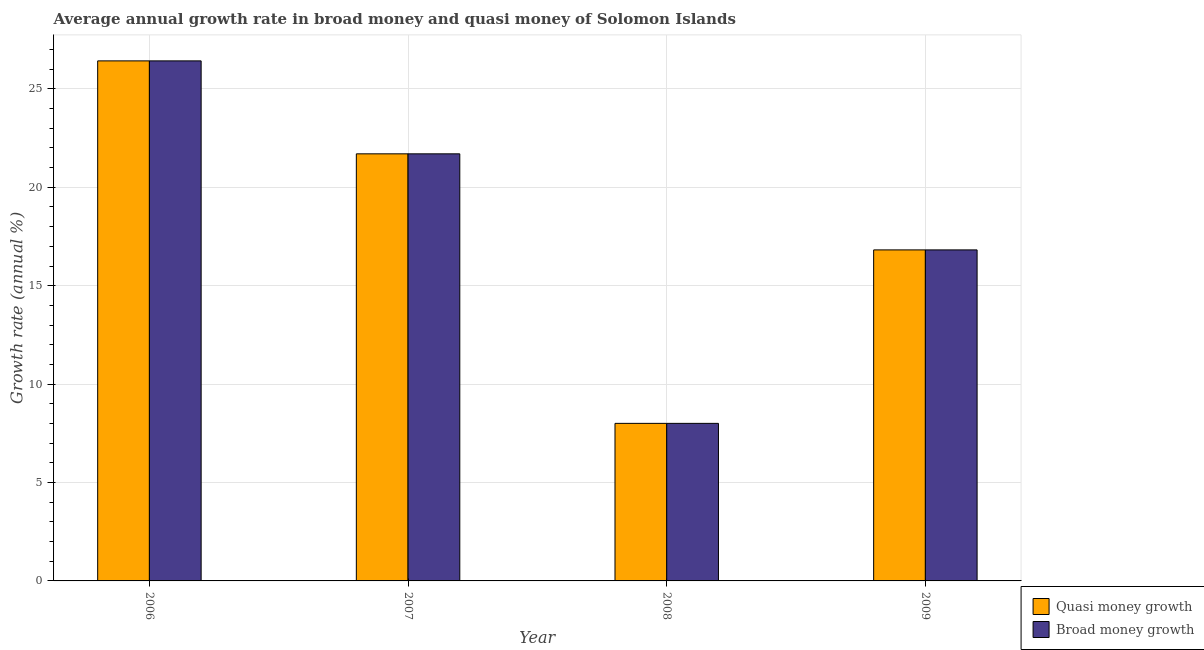How many groups of bars are there?
Your answer should be compact. 4. How many bars are there on the 2nd tick from the right?
Keep it short and to the point. 2. What is the label of the 1st group of bars from the left?
Your answer should be compact. 2006. In how many cases, is the number of bars for a given year not equal to the number of legend labels?
Provide a short and direct response. 0. What is the annual growth rate in broad money in 2008?
Keep it short and to the point. 8.01. Across all years, what is the maximum annual growth rate in broad money?
Provide a short and direct response. 26.42. Across all years, what is the minimum annual growth rate in broad money?
Your answer should be compact. 8.01. In which year was the annual growth rate in quasi money maximum?
Keep it short and to the point. 2006. In which year was the annual growth rate in broad money minimum?
Provide a succinct answer. 2008. What is the total annual growth rate in quasi money in the graph?
Provide a short and direct response. 72.95. What is the difference between the annual growth rate in quasi money in 2006 and that in 2008?
Your answer should be compact. 18.42. What is the difference between the annual growth rate in quasi money in 2006 and the annual growth rate in broad money in 2007?
Make the answer very short. 4.72. What is the average annual growth rate in quasi money per year?
Keep it short and to the point. 18.24. In the year 2006, what is the difference between the annual growth rate in broad money and annual growth rate in quasi money?
Provide a short and direct response. 0. What is the ratio of the annual growth rate in quasi money in 2007 to that in 2009?
Make the answer very short. 1.29. What is the difference between the highest and the second highest annual growth rate in broad money?
Keep it short and to the point. 4.72. What is the difference between the highest and the lowest annual growth rate in quasi money?
Provide a short and direct response. 18.42. Is the sum of the annual growth rate in quasi money in 2007 and 2008 greater than the maximum annual growth rate in broad money across all years?
Ensure brevity in your answer.  Yes. What does the 1st bar from the left in 2009 represents?
Keep it short and to the point. Quasi money growth. What does the 2nd bar from the right in 2009 represents?
Provide a short and direct response. Quasi money growth. How many bars are there?
Ensure brevity in your answer.  8. Are all the bars in the graph horizontal?
Offer a very short reply. No. What is the difference between two consecutive major ticks on the Y-axis?
Offer a very short reply. 5. Does the graph contain any zero values?
Your response must be concise. No. Does the graph contain grids?
Give a very brief answer. Yes. How many legend labels are there?
Ensure brevity in your answer.  2. What is the title of the graph?
Make the answer very short. Average annual growth rate in broad money and quasi money of Solomon Islands. Does "Register a business" appear as one of the legend labels in the graph?
Provide a short and direct response. No. What is the label or title of the Y-axis?
Ensure brevity in your answer.  Growth rate (annual %). What is the Growth rate (annual %) in Quasi money growth in 2006?
Keep it short and to the point. 26.42. What is the Growth rate (annual %) in Broad money growth in 2006?
Offer a terse response. 26.42. What is the Growth rate (annual %) in Quasi money growth in 2007?
Offer a terse response. 21.7. What is the Growth rate (annual %) of Broad money growth in 2007?
Ensure brevity in your answer.  21.7. What is the Growth rate (annual %) in Quasi money growth in 2008?
Offer a very short reply. 8.01. What is the Growth rate (annual %) of Broad money growth in 2008?
Ensure brevity in your answer.  8.01. What is the Growth rate (annual %) in Quasi money growth in 2009?
Give a very brief answer. 16.82. What is the Growth rate (annual %) in Broad money growth in 2009?
Your response must be concise. 16.82. Across all years, what is the maximum Growth rate (annual %) of Quasi money growth?
Your answer should be compact. 26.42. Across all years, what is the maximum Growth rate (annual %) of Broad money growth?
Offer a terse response. 26.42. Across all years, what is the minimum Growth rate (annual %) of Quasi money growth?
Offer a very short reply. 8.01. Across all years, what is the minimum Growth rate (annual %) in Broad money growth?
Offer a very short reply. 8.01. What is the total Growth rate (annual %) of Quasi money growth in the graph?
Provide a short and direct response. 72.95. What is the total Growth rate (annual %) in Broad money growth in the graph?
Your answer should be very brief. 72.95. What is the difference between the Growth rate (annual %) in Quasi money growth in 2006 and that in 2007?
Provide a succinct answer. 4.72. What is the difference between the Growth rate (annual %) of Broad money growth in 2006 and that in 2007?
Ensure brevity in your answer.  4.72. What is the difference between the Growth rate (annual %) of Quasi money growth in 2006 and that in 2008?
Your response must be concise. 18.42. What is the difference between the Growth rate (annual %) of Broad money growth in 2006 and that in 2008?
Keep it short and to the point. 18.42. What is the difference between the Growth rate (annual %) of Quasi money growth in 2006 and that in 2009?
Your response must be concise. 9.6. What is the difference between the Growth rate (annual %) of Broad money growth in 2006 and that in 2009?
Give a very brief answer. 9.6. What is the difference between the Growth rate (annual %) of Quasi money growth in 2007 and that in 2008?
Your answer should be very brief. 13.7. What is the difference between the Growth rate (annual %) of Broad money growth in 2007 and that in 2008?
Offer a very short reply. 13.7. What is the difference between the Growth rate (annual %) of Quasi money growth in 2007 and that in 2009?
Provide a succinct answer. 4.88. What is the difference between the Growth rate (annual %) of Broad money growth in 2007 and that in 2009?
Your answer should be compact. 4.88. What is the difference between the Growth rate (annual %) in Quasi money growth in 2008 and that in 2009?
Your answer should be compact. -8.81. What is the difference between the Growth rate (annual %) in Broad money growth in 2008 and that in 2009?
Offer a terse response. -8.81. What is the difference between the Growth rate (annual %) in Quasi money growth in 2006 and the Growth rate (annual %) in Broad money growth in 2007?
Provide a succinct answer. 4.72. What is the difference between the Growth rate (annual %) in Quasi money growth in 2006 and the Growth rate (annual %) in Broad money growth in 2008?
Your answer should be compact. 18.42. What is the difference between the Growth rate (annual %) in Quasi money growth in 2006 and the Growth rate (annual %) in Broad money growth in 2009?
Your answer should be compact. 9.6. What is the difference between the Growth rate (annual %) in Quasi money growth in 2007 and the Growth rate (annual %) in Broad money growth in 2008?
Provide a succinct answer. 13.7. What is the difference between the Growth rate (annual %) of Quasi money growth in 2007 and the Growth rate (annual %) of Broad money growth in 2009?
Give a very brief answer. 4.88. What is the difference between the Growth rate (annual %) in Quasi money growth in 2008 and the Growth rate (annual %) in Broad money growth in 2009?
Provide a short and direct response. -8.81. What is the average Growth rate (annual %) of Quasi money growth per year?
Offer a terse response. 18.24. What is the average Growth rate (annual %) in Broad money growth per year?
Offer a terse response. 18.24. In the year 2006, what is the difference between the Growth rate (annual %) of Quasi money growth and Growth rate (annual %) of Broad money growth?
Your answer should be very brief. 0. In the year 2007, what is the difference between the Growth rate (annual %) in Quasi money growth and Growth rate (annual %) in Broad money growth?
Give a very brief answer. 0. In the year 2008, what is the difference between the Growth rate (annual %) of Quasi money growth and Growth rate (annual %) of Broad money growth?
Make the answer very short. 0. What is the ratio of the Growth rate (annual %) of Quasi money growth in 2006 to that in 2007?
Your answer should be very brief. 1.22. What is the ratio of the Growth rate (annual %) of Broad money growth in 2006 to that in 2007?
Ensure brevity in your answer.  1.22. What is the ratio of the Growth rate (annual %) of Quasi money growth in 2006 to that in 2008?
Offer a terse response. 3.3. What is the ratio of the Growth rate (annual %) of Broad money growth in 2006 to that in 2008?
Provide a succinct answer. 3.3. What is the ratio of the Growth rate (annual %) of Quasi money growth in 2006 to that in 2009?
Give a very brief answer. 1.57. What is the ratio of the Growth rate (annual %) of Broad money growth in 2006 to that in 2009?
Ensure brevity in your answer.  1.57. What is the ratio of the Growth rate (annual %) in Quasi money growth in 2007 to that in 2008?
Give a very brief answer. 2.71. What is the ratio of the Growth rate (annual %) in Broad money growth in 2007 to that in 2008?
Make the answer very short. 2.71. What is the ratio of the Growth rate (annual %) in Quasi money growth in 2007 to that in 2009?
Your response must be concise. 1.29. What is the ratio of the Growth rate (annual %) of Broad money growth in 2007 to that in 2009?
Provide a short and direct response. 1.29. What is the ratio of the Growth rate (annual %) of Quasi money growth in 2008 to that in 2009?
Provide a succinct answer. 0.48. What is the ratio of the Growth rate (annual %) of Broad money growth in 2008 to that in 2009?
Make the answer very short. 0.48. What is the difference between the highest and the second highest Growth rate (annual %) of Quasi money growth?
Give a very brief answer. 4.72. What is the difference between the highest and the second highest Growth rate (annual %) in Broad money growth?
Keep it short and to the point. 4.72. What is the difference between the highest and the lowest Growth rate (annual %) of Quasi money growth?
Ensure brevity in your answer.  18.42. What is the difference between the highest and the lowest Growth rate (annual %) in Broad money growth?
Your response must be concise. 18.42. 